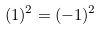Convert formula to latex. <formula><loc_0><loc_0><loc_500><loc_500>( 1 ) ^ { 2 } = ( - 1 ) ^ { 2 }</formula> 